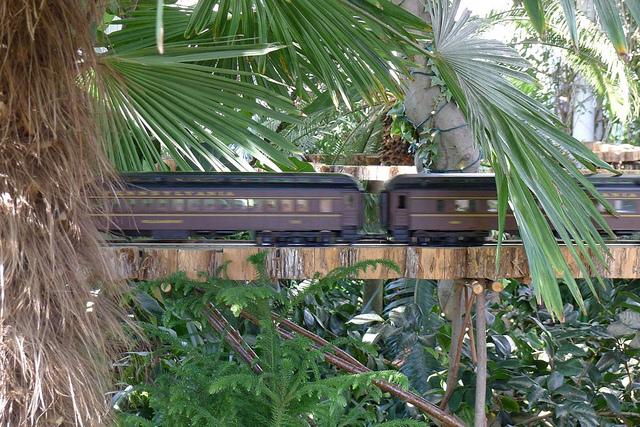Is this a real train or a toy train?
Answer briefly. Toy. What kind of tree is covering the train?
Quick response, please. Palm. Do you think this is a normal sized train?
Answer briefly. No. 